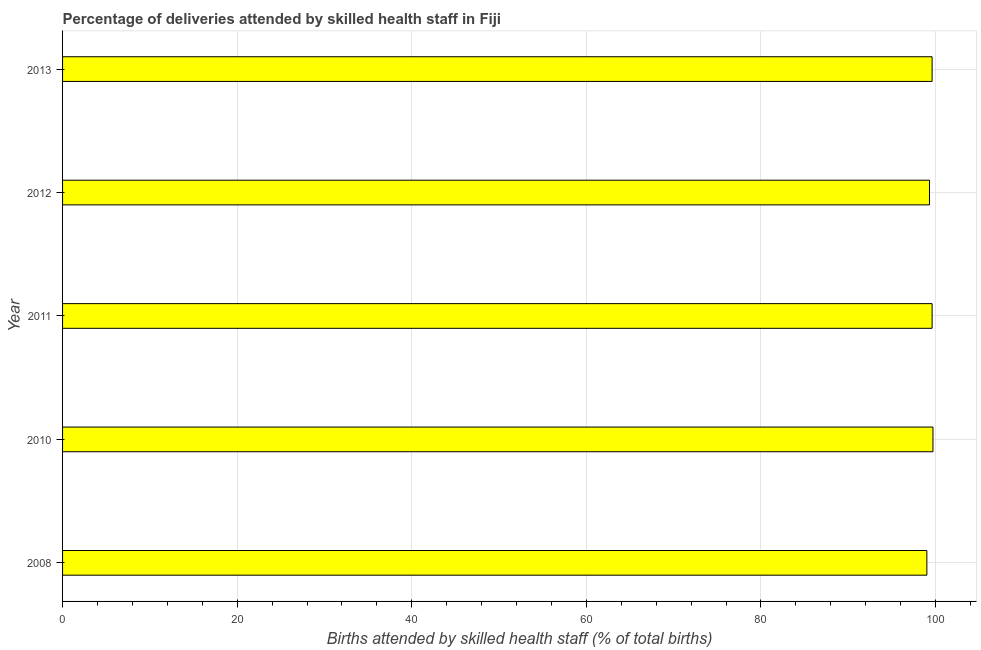Does the graph contain grids?
Your answer should be very brief. Yes. What is the title of the graph?
Your answer should be very brief. Percentage of deliveries attended by skilled health staff in Fiji. What is the label or title of the X-axis?
Make the answer very short. Births attended by skilled health staff (% of total births). What is the label or title of the Y-axis?
Offer a very short reply. Year. What is the number of births attended by skilled health staff in 2011?
Give a very brief answer. 99.6. Across all years, what is the maximum number of births attended by skilled health staff?
Provide a short and direct response. 99.7. What is the sum of the number of births attended by skilled health staff?
Provide a succinct answer. 497.2. What is the difference between the number of births attended by skilled health staff in 2010 and 2012?
Make the answer very short. 0.4. What is the average number of births attended by skilled health staff per year?
Provide a succinct answer. 99.44. What is the median number of births attended by skilled health staff?
Provide a short and direct response. 99.6. Do a majority of the years between 2008 and 2013 (inclusive) have number of births attended by skilled health staff greater than 96 %?
Offer a very short reply. Yes. Is the number of births attended by skilled health staff in 2011 less than that in 2012?
Make the answer very short. No. Is the sum of the number of births attended by skilled health staff in 2011 and 2012 greater than the maximum number of births attended by skilled health staff across all years?
Provide a succinct answer. Yes. What is the difference between the highest and the lowest number of births attended by skilled health staff?
Your answer should be very brief. 0.7. How many years are there in the graph?
Give a very brief answer. 5. What is the difference between two consecutive major ticks on the X-axis?
Your response must be concise. 20. What is the Births attended by skilled health staff (% of total births) in 2008?
Offer a terse response. 99. What is the Births attended by skilled health staff (% of total births) of 2010?
Offer a very short reply. 99.7. What is the Births attended by skilled health staff (% of total births) of 2011?
Offer a terse response. 99.6. What is the Births attended by skilled health staff (% of total births) in 2012?
Offer a very short reply. 99.3. What is the Births attended by skilled health staff (% of total births) in 2013?
Offer a very short reply. 99.6. What is the difference between the Births attended by skilled health staff (% of total births) in 2008 and 2010?
Your response must be concise. -0.7. What is the difference between the Births attended by skilled health staff (% of total births) in 2008 and 2012?
Your answer should be very brief. -0.3. What is the difference between the Births attended by skilled health staff (% of total births) in 2008 and 2013?
Ensure brevity in your answer.  -0.6. What is the difference between the Births attended by skilled health staff (% of total births) in 2010 and 2012?
Provide a short and direct response. 0.4. What is the difference between the Births attended by skilled health staff (% of total births) in 2011 and 2012?
Make the answer very short. 0.3. What is the ratio of the Births attended by skilled health staff (% of total births) in 2008 to that in 2010?
Keep it short and to the point. 0.99. What is the ratio of the Births attended by skilled health staff (% of total births) in 2008 to that in 2012?
Offer a terse response. 1. 